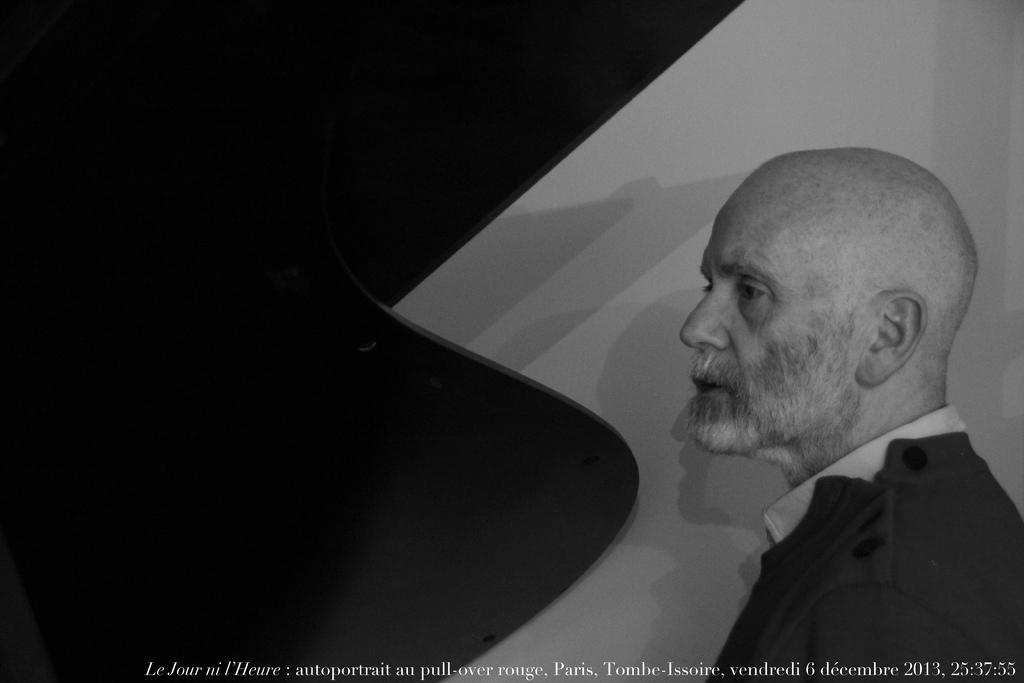What is the color scheme of the image? The image is black and white. Can you describe the person in the image? There is a man in the image. What is the man wearing? The man is wearing clothes. Is there any text or marking at the bottom of the image? Yes, there is a watermark at the bottom of the image. Can you tell me how many oranges are on the table in the image? There are no oranges present in the image. What type of experience does the man in the image have? The image does not provide any information about the man's experience or background. 